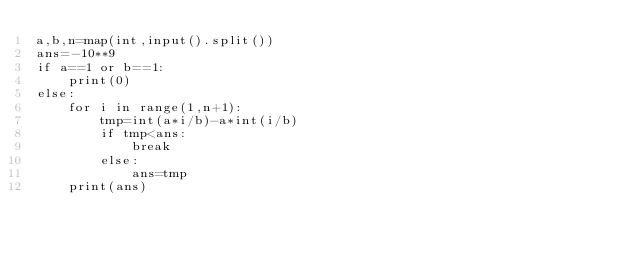Convert code to text. <code><loc_0><loc_0><loc_500><loc_500><_Python_>a,b,n=map(int,input().split())
ans=-10**9
if a==1 or b==1:
    print(0)
else:
    for i in range(1,n+1):
        tmp=int(a*i/b)-a*int(i/b)
        if tmp<ans:
            break
        else:
            ans=tmp
    print(ans)</code> 